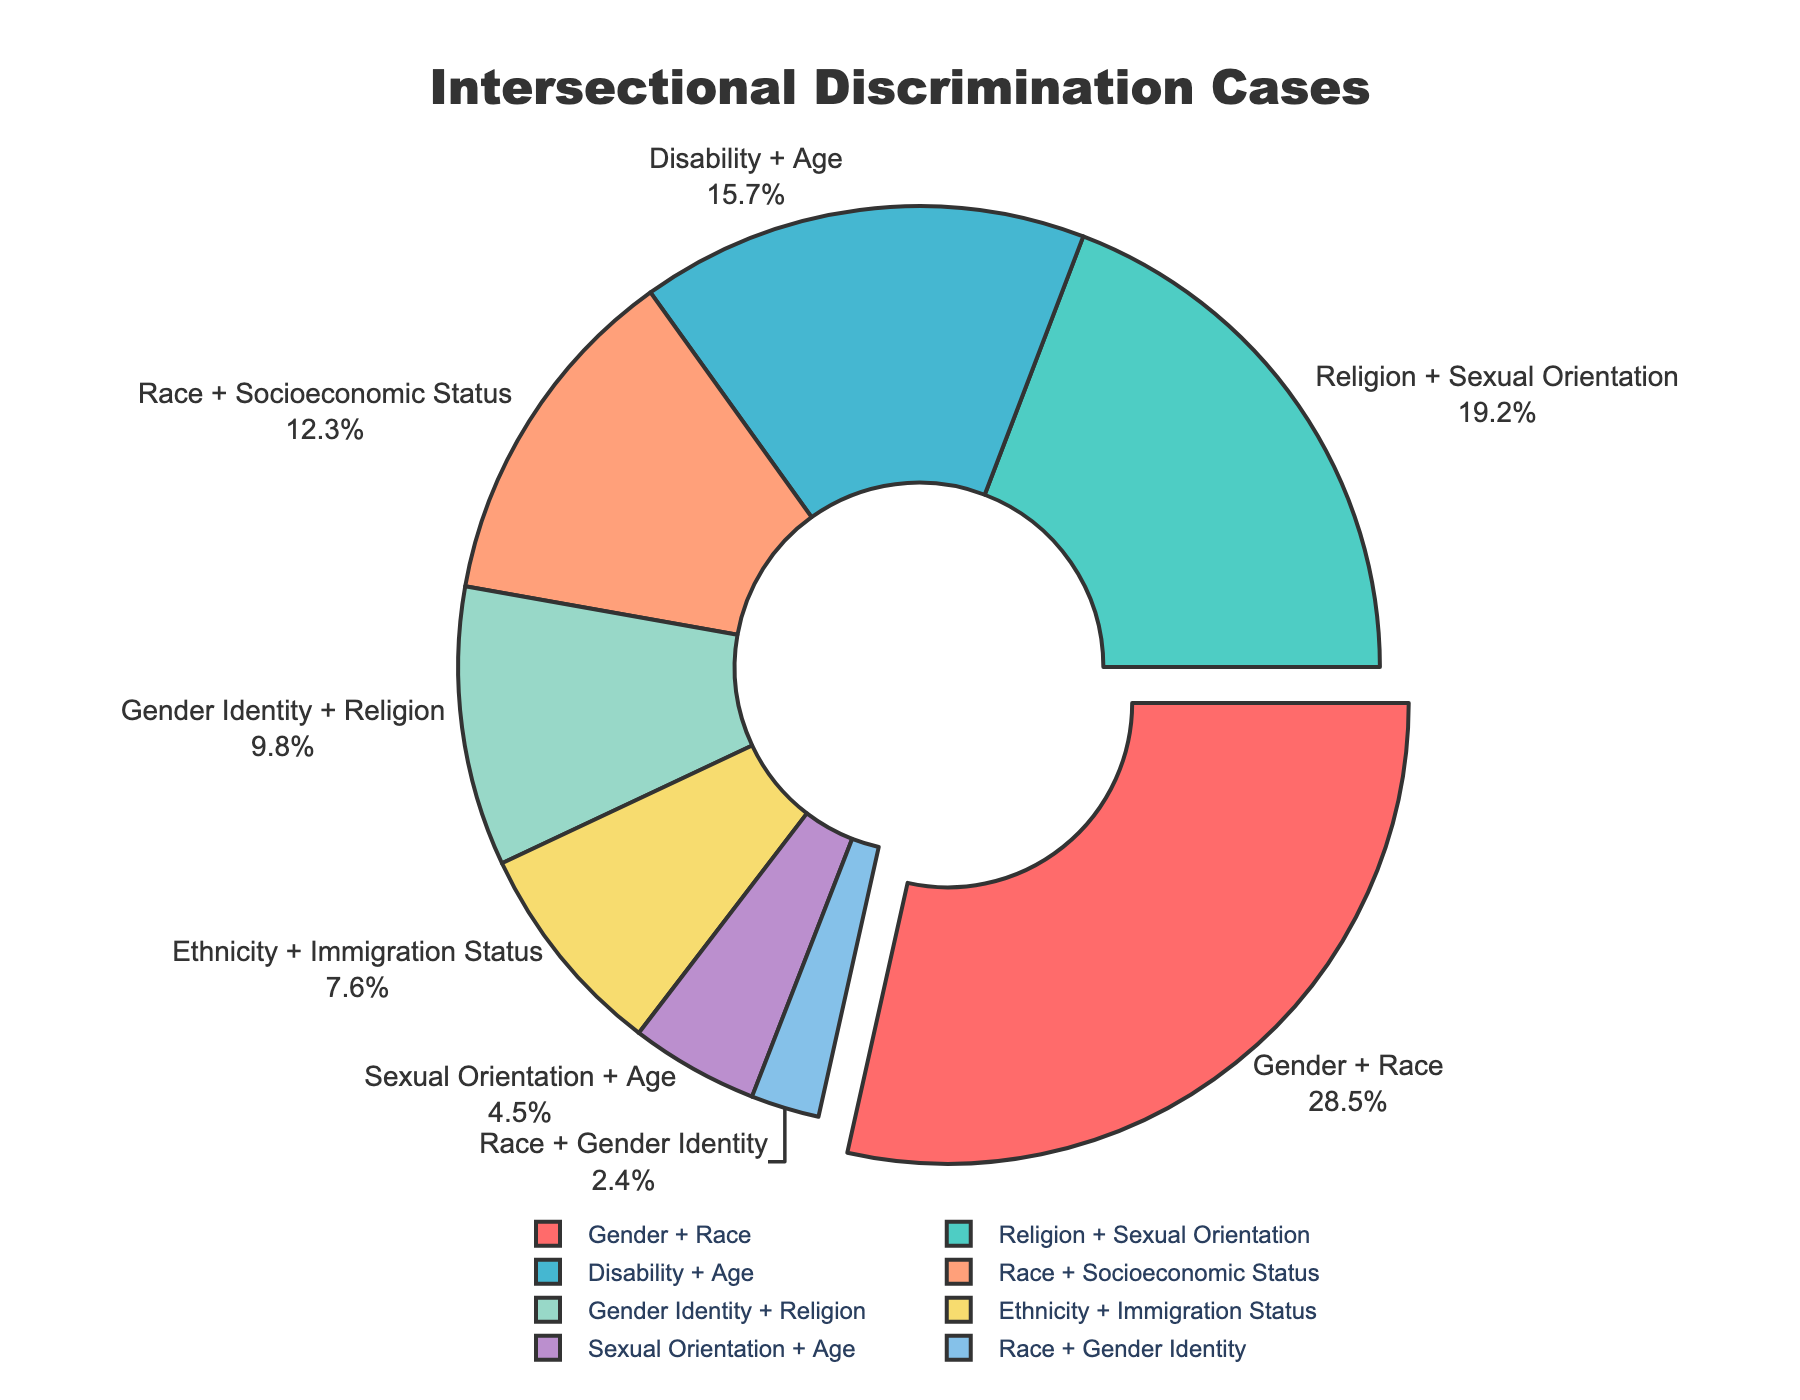What category has the highest percentage of reported discrimination cases? The category with the highest percentage can be identified by looking at the pie chart segment that is pulled out from the rest. This segment corresponds to "Gender + Race", which has a percentage of 28.5%.
Answer: Gender + Race Which category has a lower percentage of reported cases, Disability + Age or Race + Socioeconomic Status? Comparing the two percentages, Disability + Age has 15.7% and Race + Socioeconomic Status has 12.3%. Since 12.3% is less than 15.7%, Race + Socioeconomic Status has a lower percentage.
Answer: Race + Socioeconomic Status What is the combined percentage of the two categories with the lowest reported discrimination cases? Identify the two categories with the lowest percentages, which are Race + Gender Identity (2.4%) and Sexual Orientation + Age (4.5%). Add these percentages together: 2.4% + 4.5% = 6.9%.
Answer: 6.9% What percentage of the reported discrimination cases involve intersections that include Gender? Identify the categories involving Gender: Gender + Race (28.5%) and Gender Identity + Religion (9.8%). Sum these percentages: 28.5% + 9.8% = 38.3%.
Answer: 38.3% How does the percentage of Religion + Sexual Orientation compare to that of Gender Identity + Religion? Religion + Sexual Orientation has a percentage of 19.2%, while Gender Identity + Religion has 9.8%. Comparing these, Religion + Sexual Orientation has a higher percentage.
Answer: Religion + Sexual Orientation Which segment of the pie chart is represented by a green color? By visually inspecting the color coding of the segments in the pie chart, the green segment corresponds to "Religion + Sexual Orientation".
Answer: Religion + Sexual Orientation What is the difference in percentage between the highest and lowest reported discrimination categories? The highest percentage is for Gender + Race (28.5%), and the lowest is Race + Gender Identity (2.4%). The difference is calculated as 28.5% - 2.4% = 26.1%.
Answer: 26.1% What is the total percentage of discrimination cases reported based on intersections involving Race? Identify the categories involving Race: Gender + Race (28.5%), Race + Socioeconomic Status (12.3%), and Race + Gender Identity (2.4%). Sum these percentages: 28.5% + 12.3% + 2.4% = 43.2%.
Answer: 43.2% By how much does the percentage of Religion + Sexual Orientation exceed that of Ethnicity + Immigration Status? The percentage for Religion + Sexual Orientation is 19.2%, and for Ethnicity + Immigration Status, it is 7.6%. The difference is 19.2% - 7.6% = 11.6%.
Answer: 11.6% If you combine the percentages of categories involving Religion, what is the total percentage? Identify the categories involving Religion: Religion + Sexual Orientation (19.2%) and Gender Identity + Religion (9.8%). Sum these percentages: 19.2% + 9.8% = 29%.
Answer: 29% 